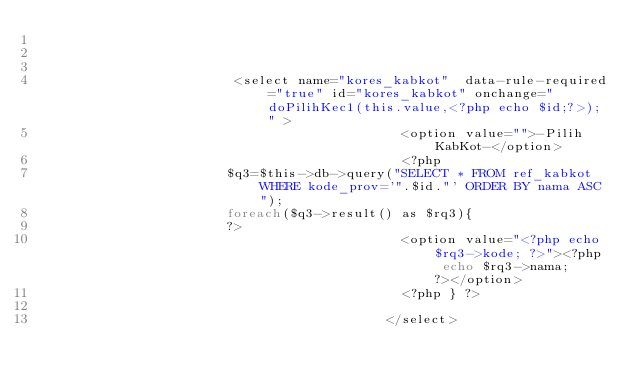Convert code to text. <code><loc_0><loc_0><loc_500><loc_500><_PHP_>
										

												 <select name="kores_kabkot"  data-rule-required="true" id="kores_kabkot" onchange="doPilihKec1(this.value,<?php echo $id;?>);" >
                                              <option value="">-Pilih KabKot-</option>
                                              <?php 
											  $q3=$this->db->query("SELECT * FROM ref_kabkot WHERE kode_prov='".$id."' ORDER BY nama ASC");
											  foreach($q3->result() as $rq3){
											  ?>
                                              <option value="<?php echo $rq3->kode; ?>"><?php echo $rq3->nama; ?></option>
                                              <?php } ?>
                                              
                                            </select>
											</code> 